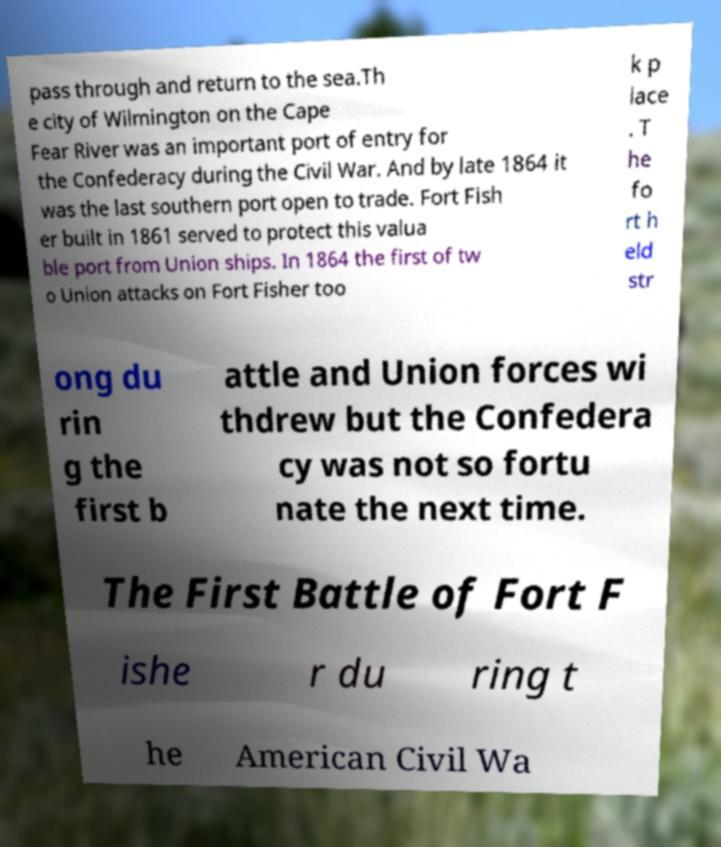For documentation purposes, I need the text within this image transcribed. Could you provide that? pass through and return to the sea.Th e city of Wilmington on the Cape Fear River was an important port of entry for the Confederacy during the Civil War. And by late 1864 it was the last southern port open to trade. Fort Fish er built in 1861 served to protect this valua ble port from Union ships. In 1864 the first of tw o Union attacks on Fort Fisher too k p lace . T he fo rt h eld str ong du rin g the first b attle and Union forces wi thdrew but the Confedera cy was not so fortu nate the next time. The First Battle of Fort F ishe r du ring t he American Civil Wa 